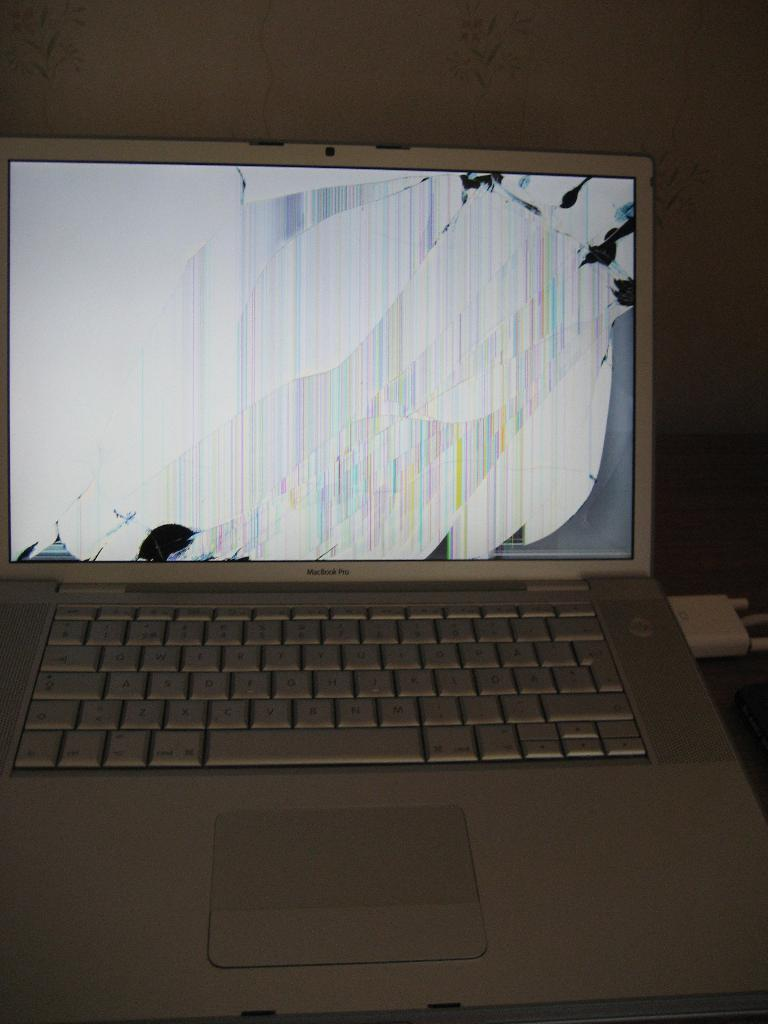<image>
Render a clear and concise summary of the photo. Macbook Pro laptop screen that is currently cracked. 